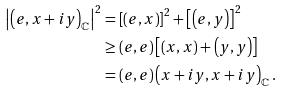Convert formula to latex. <formula><loc_0><loc_0><loc_500><loc_500>\left | \left ( e , x + i y \right ) _ { \mathbb { C } } \right | ^ { 2 } & = \left [ \left ( e , x \right ) \right ] ^ { 2 } + \left [ \left ( e , y \right ) \right ] ^ { 2 } \\ & \geq \left ( e , e \right ) \left [ \left ( x , x \right ) + \left ( y , y \right ) \right ] \\ & = \left ( e , e \right ) \left ( x + i y , x + i y \right ) _ { \mathbb { C } } .</formula> 